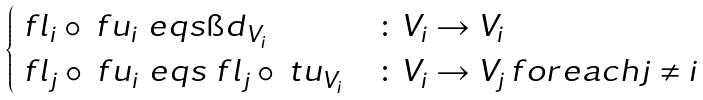<formula> <loc_0><loc_0><loc_500><loc_500>\begin{cases} \ f l _ { i } \circ \ f u _ { i } \ e q s \i d _ { V _ { i } } & \colon V _ { i } \to V _ { i } \\ \ f l _ { j } \circ \ f u _ { i } \ e q s \ f l _ { j } \circ \ t u _ { V _ { i } } & \colon V _ { i } \to V _ { j } \, f o r e a c h j \ne i \\ \end{cases}</formula> 